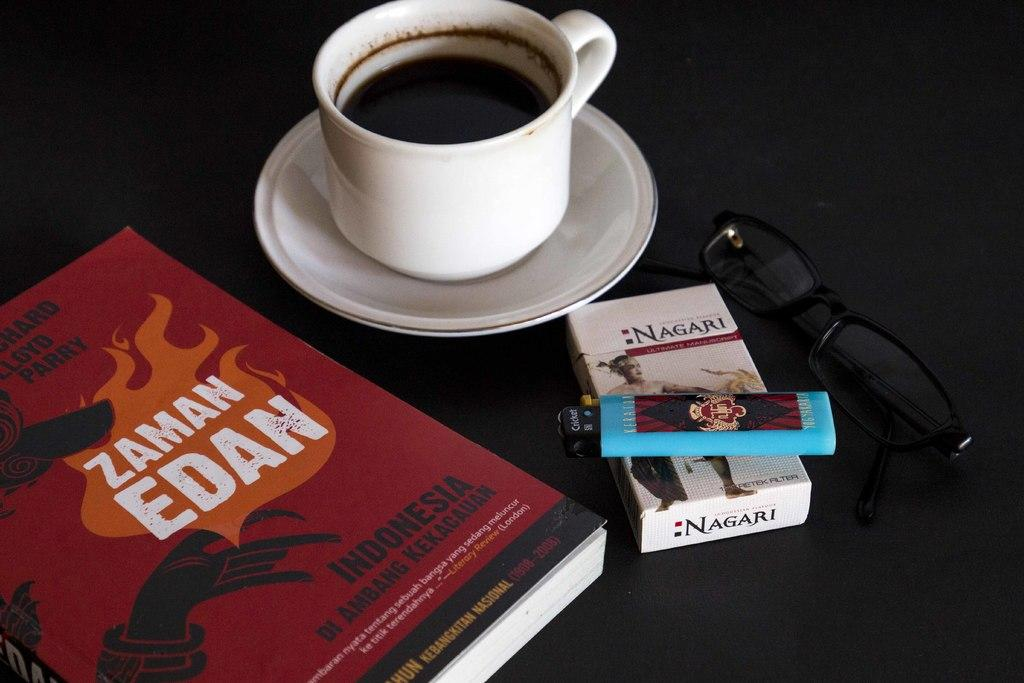<image>
Describe the image concisely. A cup of coffee next to a book titled " Zaman Edan" and a pack of cigarettes and a lighter on the table 